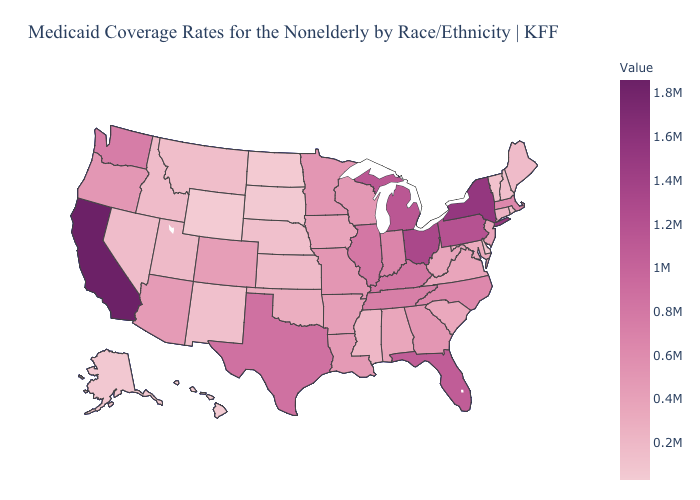Among the states that border Utah , which have the lowest value?
Be succinct. Wyoming. Does Hawaii have the lowest value in the USA?
Short answer required. Yes. Is the legend a continuous bar?
Short answer required. Yes. Among the states that border Maryland , which have the highest value?
Write a very short answer. Pennsylvania. Is the legend a continuous bar?
Give a very brief answer. Yes. Does Massachusetts have a lower value than Pennsylvania?
Concise answer only. Yes. 